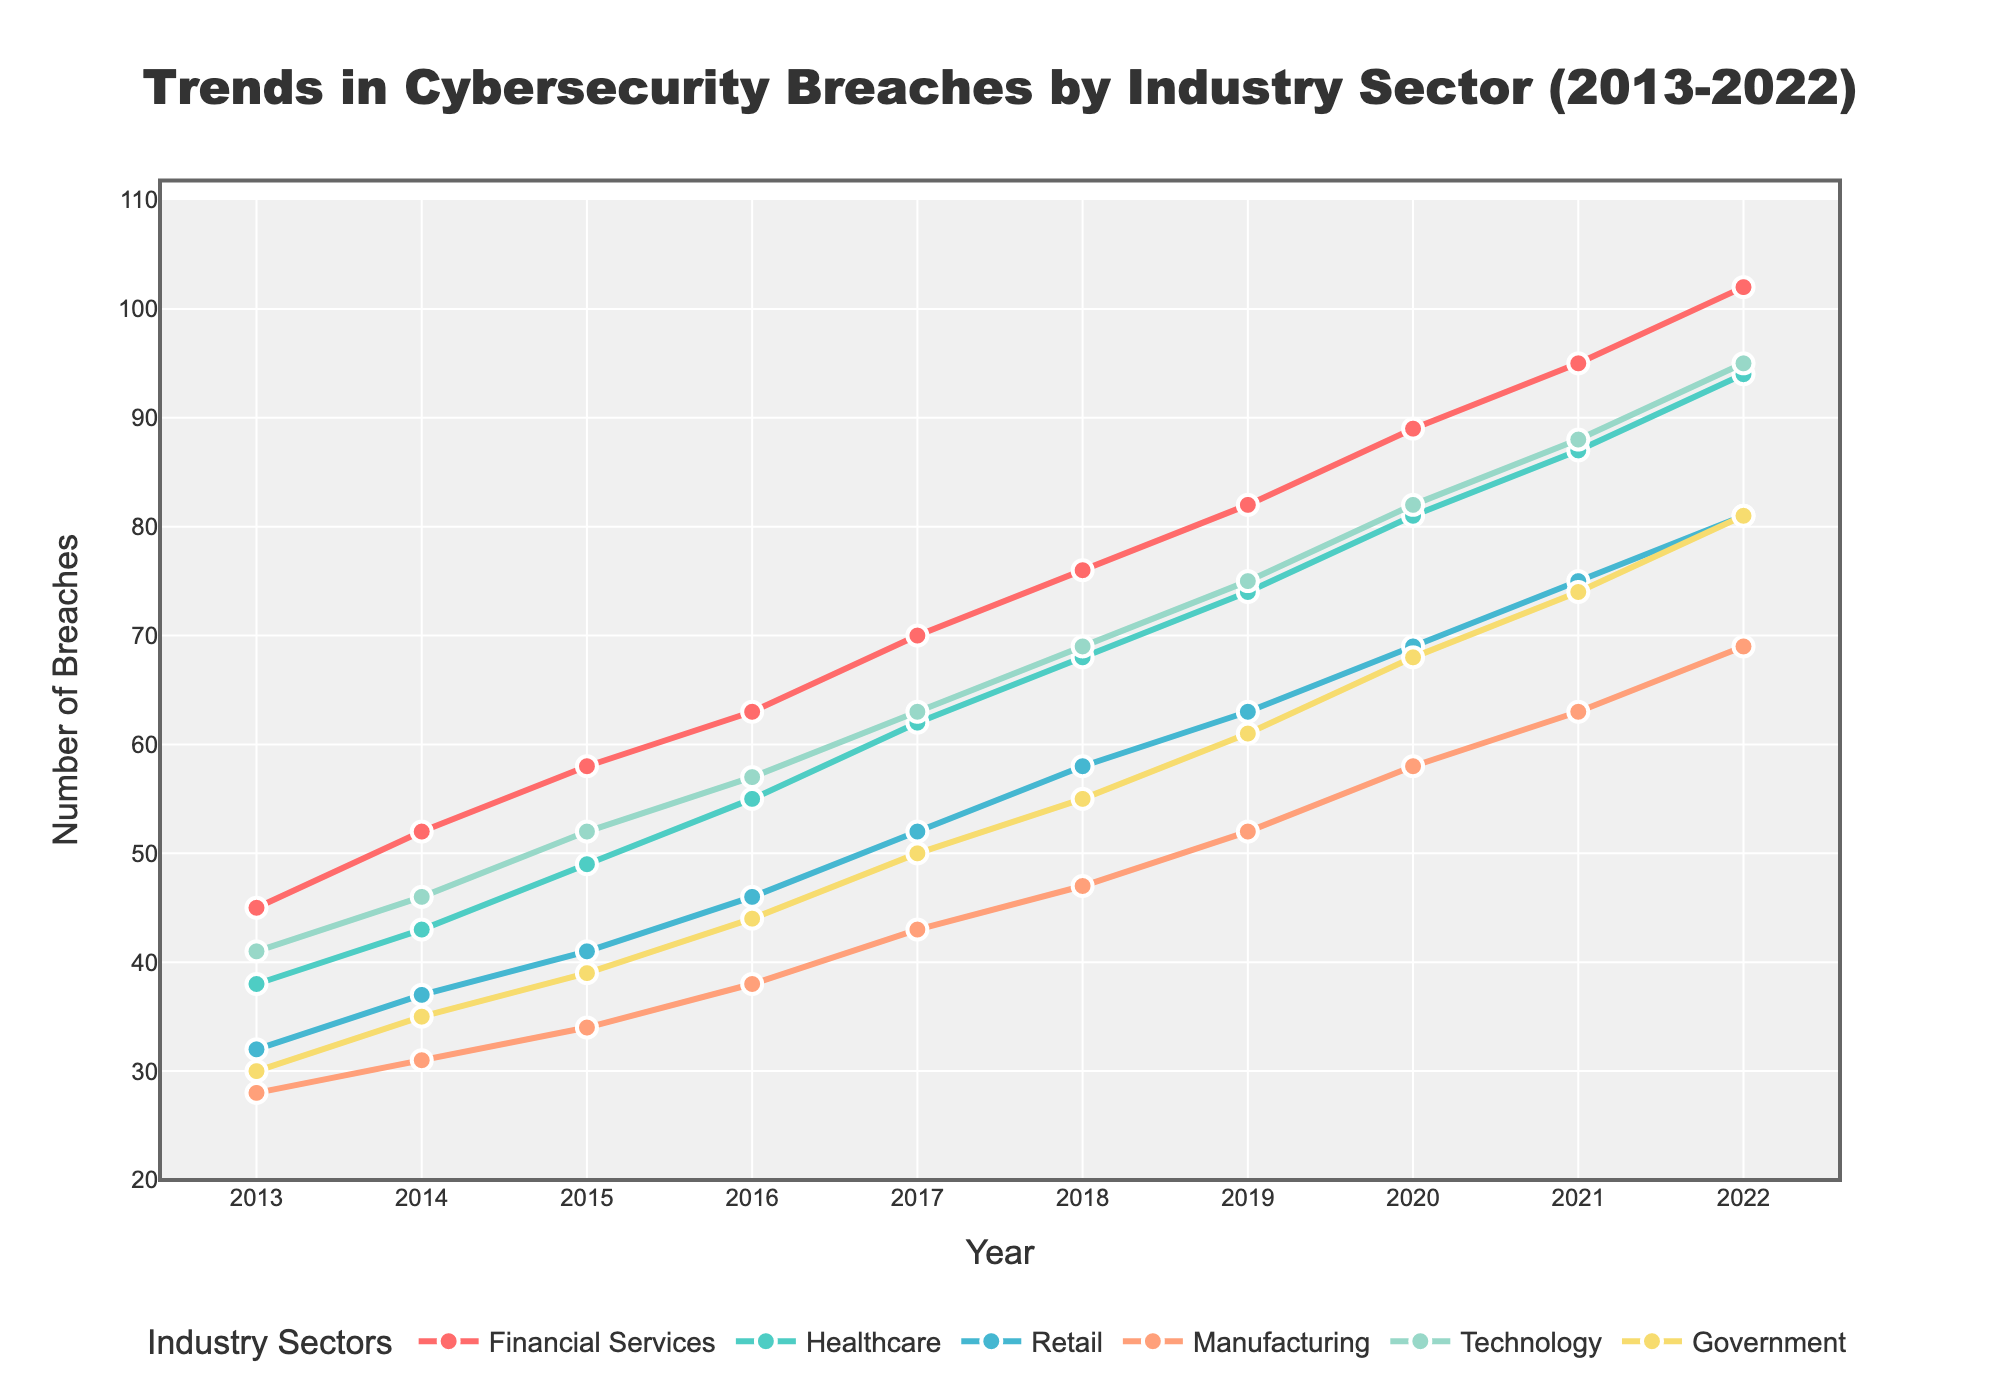Which industry sector had the highest number of cybersecurity breaches in 2022? In the figure, the Technology sector shows the highest point on the y-axis among all sectors in the year 2022.
Answer: Technology How did the number of breaches in the Financial Services sector change from 2013 to 2022? By following the Financial Services line from 2013 to 2022, we see an increasing trend. It increased from 45 in 2013 to 102 in 2022.
Answer: Increased from 45 to 102 Which industry had a greater increase in breaches from 2013 to 2014, Healthcare or Retail? For Healthcare, the breaches went from 38 in 2013 to 43 in 2014, an increase of 5. For Retail, the breaches went from 32 in 2013 to 37 in 2014, an increase of 5. Since both sectors have an equal increase in breaches, there is no greater increase.
Answer: Equal increase Compare the trends in cybersecurity breaches between Government and Manufacturing sectors from 2013 to 2022. By analyzing both lines, we see that Government's breaches increased from 30 to 81, while Manufacturing's breaches increased from 28 to 69 over the same period. Both sectors show an increasing trend, but Government has a higher overall number of breaches and a steeper increase.
Answer: Government had a steeper increase and higher number of breaches What is the average number of breaches in the Manufacturing sector for the years shown? To find the average, sum the breaches for Manufacturing from 2013 to 2022 (28 + 31 + 34 + 38 + 43 + 47 + 52 + 58 + 63 + 69) = 463; then divide by 10 (the number of years) giving 463 / 10 = 46.3
Answer: 46.3 